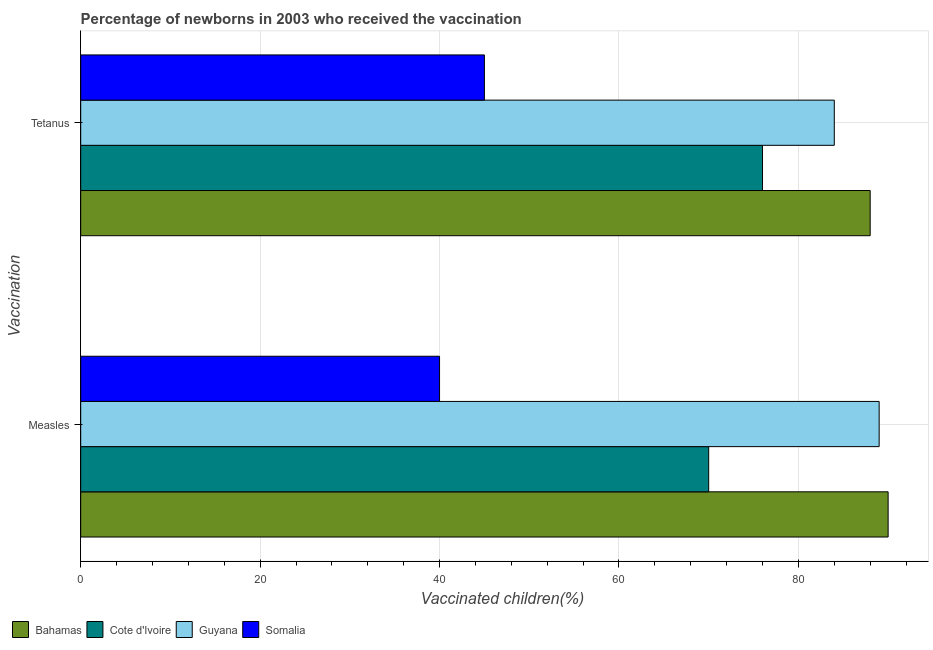How many groups of bars are there?
Provide a succinct answer. 2. Are the number of bars per tick equal to the number of legend labels?
Provide a succinct answer. Yes. What is the label of the 1st group of bars from the top?
Keep it short and to the point. Tetanus. What is the percentage of newborns who received vaccination for tetanus in Bahamas?
Offer a terse response. 88. Across all countries, what is the maximum percentage of newborns who received vaccination for measles?
Provide a short and direct response. 90. Across all countries, what is the minimum percentage of newborns who received vaccination for tetanus?
Provide a succinct answer. 45. In which country was the percentage of newborns who received vaccination for tetanus maximum?
Your answer should be compact. Bahamas. In which country was the percentage of newborns who received vaccination for tetanus minimum?
Your answer should be very brief. Somalia. What is the total percentage of newborns who received vaccination for tetanus in the graph?
Offer a terse response. 293. What is the difference between the percentage of newborns who received vaccination for measles in Guyana and that in Bahamas?
Your answer should be compact. -1. What is the difference between the percentage of newborns who received vaccination for tetanus in Somalia and the percentage of newborns who received vaccination for measles in Guyana?
Keep it short and to the point. -44. What is the average percentage of newborns who received vaccination for tetanus per country?
Give a very brief answer. 73.25. In how many countries, is the percentage of newborns who received vaccination for tetanus greater than 44 %?
Provide a short and direct response. 4. What is the ratio of the percentage of newborns who received vaccination for tetanus in Guyana to that in Somalia?
Keep it short and to the point. 1.87. Is the percentage of newborns who received vaccination for tetanus in Guyana less than that in Somalia?
Your answer should be compact. No. In how many countries, is the percentage of newborns who received vaccination for tetanus greater than the average percentage of newborns who received vaccination for tetanus taken over all countries?
Provide a succinct answer. 3. What does the 3rd bar from the top in Tetanus represents?
Your answer should be very brief. Cote d'Ivoire. What does the 4th bar from the bottom in Tetanus represents?
Keep it short and to the point. Somalia. How many bars are there?
Your answer should be compact. 8. Are all the bars in the graph horizontal?
Make the answer very short. Yes. What is the difference between two consecutive major ticks on the X-axis?
Provide a short and direct response. 20. Does the graph contain any zero values?
Your response must be concise. No. Does the graph contain grids?
Ensure brevity in your answer.  Yes. Where does the legend appear in the graph?
Keep it short and to the point. Bottom left. What is the title of the graph?
Ensure brevity in your answer.  Percentage of newborns in 2003 who received the vaccination. Does "France" appear as one of the legend labels in the graph?
Offer a very short reply. No. What is the label or title of the X-axis?
Ensure brevity in your answer.  Vaccinated children(%)
. What is the label or title of the Y-axis?
Offer a very short reply. Vaccination. What is the Vaccinated children(%)
 of Bahamas in Measles?
Make the answer very short. 90. What is the Vaccinated children(%)
 in Guyana in Measles?
Keep it short and to the point. 89. What is the Vaccinated children(%)
 of Cote d'Ivoire in Tetanus?
Offer a very short reply. 76. What is the Vaccinated children(%)
 in Guyana in Tetanus?
Keep it short and to the point. 84. Across all Vaccination, what is the maximum Vaccinated children(%)
 of Cote d'Ivoire?
Your answer should be compact. 76. Across all Vaccination, what is the maximum Vaccinated children(%)
 of Guyana?
Your answer should be very brief. 89. Across all Vaccination, what is the minimum Vaccinated children(%)
 of Bahamas?
Give a very brief answer. 88. Across all Vaccination, what is the minimum Vaccinated children(%)
 in Cote d'Ivoire?
Make the answer very short. 70. Across all Vaccination, what is the minimum Vaccinated children(%)
 of Guyana?
Offer a very short reply. 84. Across all Vaccination, what is the minimum Vaccinated children(%)
 of Somalia?
Give a very brief answer. 40. What is the total Vaccinated children(%)
 of Bahamas in the graph?
Your answer should be compact. 178. What is the total Vaccinated children(%)
 in Cote d'Ivoire in the graph?
Provide a short and direct response. 146. What is the total Vaccinated children(%)
 in Guyana in the graph?
Your answer should be compact. 173. What is the difference between the Vaccinated children(%)
 of Bahamas in Measles and that in Tetanus?
Offer a terse response. 2. What is the difference between the Vaccinated children(%)
 of Cote d'Ivoire in Measles and that in Tetanus?
Give a very brief answer. -6. What is the difference between the Vaccinated children(%)
 in Guyana in Measles and that in Tetanus?
Offer a terse response. 5. What is the difference between the Vaccinated children(%)
 of Somalia in Measles and that in Tetanus?
Give a very brief answer. -5. What is the difference between the Vaccinated children(%)
 in Bahamas in Measles and the Vaccinated children(%)
 in Cote d'Ivoire in Tetanus?
Make the answer very short. 14. What is the difference between the Vaccinated children(%)
 in Bahamas in Measles and the Vaccinated children(%)
 in Guyana in Tetanus?
Make the answer very short. 6. What is the difference between the Vaccinated children(%)
 in Bahamas in Measles and the Vaccinated children(%)
 in Somalia in Tetanus?
Provide a succinct answer. 45. What is the difference between the Vaccinated children(%)
 in Cote d'Ivoire in Measles and the Vaccinated children(%)
 in Somalia in Tetanus?
Your answer should be compact. 25. What is the difference between the Vaccinated children(%)
 of Guyana in Measles and the Vaccinated children(%)
 of Somalia in Tetanus?
Offer a terse response. 44. What is the average Vaccinated children(%)
 in Bahamas per Vaccination?
Your answer should be compact. 89. What is the average Vaccinated children(%)
 of Cote d'Ivoire per Vaccination?
Provide a succinct answer. 73. What is the average Vaccinated children(%)
 in Guyana per Vaccination?
Provide a short and direct response. 86.5. What is the average Vaccinated children(%)
 in Somalia per Vaccination?
Provide a short and direct response. 42.5. What is the difference between the Vaccinated children(%)
 of Cote d'Ivoire and Vaccinated children(%)
 of Guyana in Measles?
Your answer should be very brief. -19. What is the difference between the Vaccinated children(%)
 in Cote d'Ivoire and Vaccinated children(%)
 in Somalia in Measles?
Ensure brevity in your answer.  30. What is the difference between the Vaccinated children(%)
 in Guyana and Vaccinated children(%)
 in Somalia in Measles?
Keep it short and to the point. 49. What is the difference between the Vaccinated children(%)
 in Bahamas and Vaccinated children(%)
 in Cote d'Ivoire in Tetanus?
Your response must be concise. 12. What is the difference between the Vaccinated children(%)
 of Cote d'Ivoire and Vaccinated children(%)
 of Guyana in Tetanus?
Your answer should be very brief. -8. What is the ratio of the Vaccinated children(%)
 in Bahamas in Measles to that in Tetanus?
Make the answer very short. 1.02. What is the ratio of the Vaccinated children(%)
 in Cote d'Ivoire in Measles to that in Tetanus?
Offer a very short reply. 0.92. What is the ratio of the Vaccinated children(%)
 in Guyana in Measles to that in Tetanus?
Your answer should be very brief. 1.06. What is the difference between the highest and the second highest Vaccinated children(%)
 in Bahamas?
Offer a terse response. 2. What is the difference between the highest and the lowest Vaccinated children(%)
 of Cote d'Ivoire?
Provide a short and direct response. 6. What is the difference between the highest and the lowest Vaccinated children(%)
 in Guyana?
Your response must be concise. 5. 